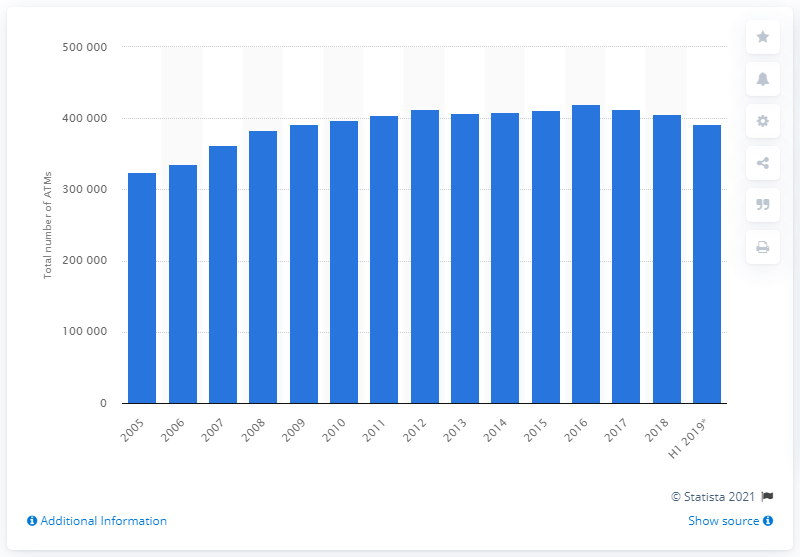Point out several critical features in this image. In 2005, there were approximately 324,797 ATMs in Europe. There were approximately 420,200 ATMs in Europe in the year 2016. There were 391,434 ATMs in Europe during the first half of 2019. 